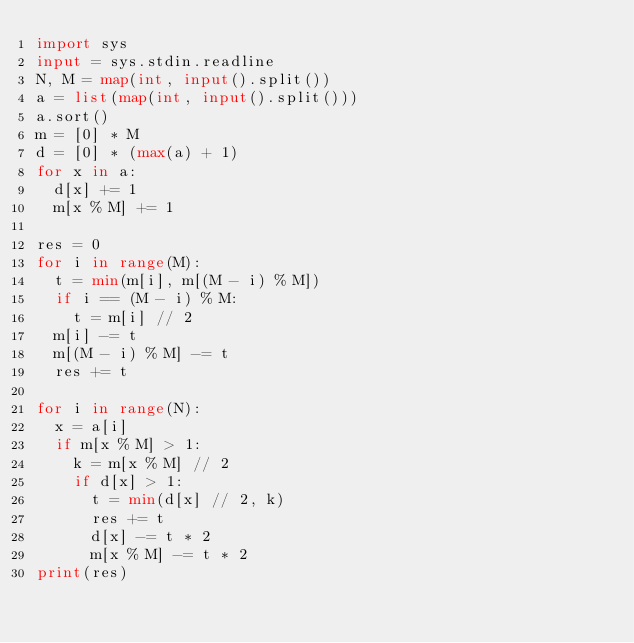<code> <loc_0><loc_0><loc_500><loc_500><_Python_>import sys
input = sys.stdin.readline
N, M = map(int, input().split())
a = list(map(int, input().split()))
a.sort()
m = [0] * M
d = [0] * (max(a) + 1)
for x in a:
  d[x] += 1
  m[x % M] += 1

res = 0
for i in range(M):
  t = min(m[i], m[(M - i) % M])
  if i == (M - i) % M:
    t = m[i] // 2
  m[i] -= t
  m[(M - i) % M] -= t
  res += t

for i in range(N):
  x = a[i]
  if m[x % M] > 1:
    k = m[x % M] // 2
    if d[x] > 1:
      t = min(d[x] // 2, k)
      res += t
      d[x] -= t * 2
      m[x % M] -= t * 2
print(res)
</code> 